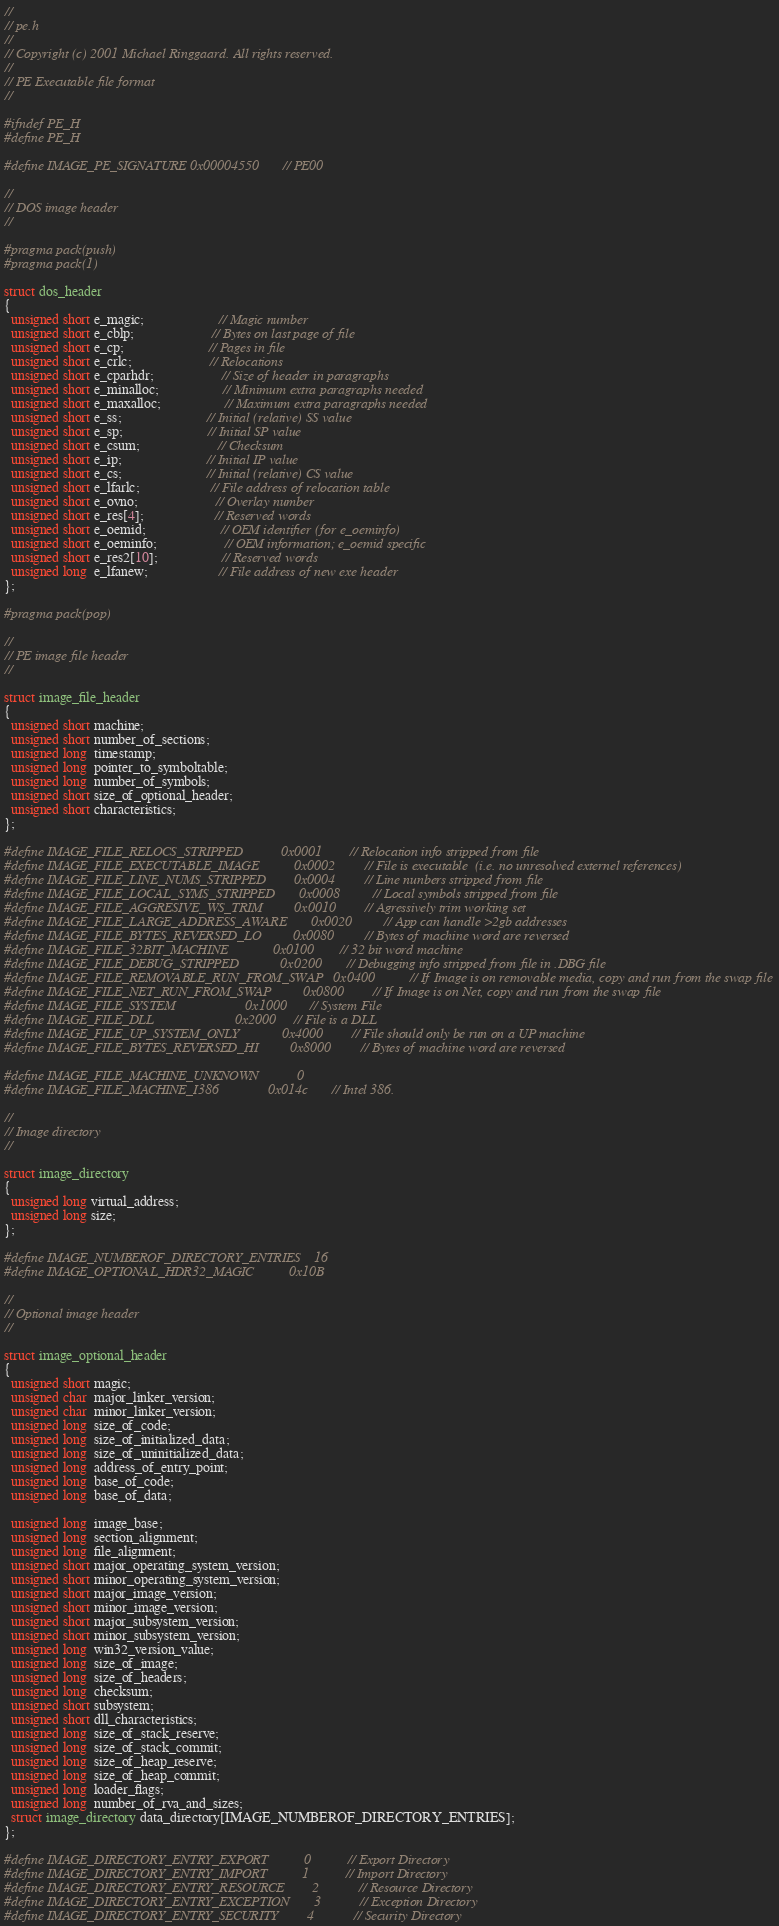<code> <loc_0><loc_0><loc_500><loc_500><_C_>//
// pe.h
//
// Copyright (c) 2001 Michael Ringgaard. All rights reserved.
//
// PE Executable file format
//

#ifndef PE_H
#define PE_H

#define IMAGE_PE_SIGNATURE 0x00004550  // PE00

//
// DOS image header
//

#pragma pack(push)
#pragma pack(1)

struct dos_header 
{
  unsigned short e_magic;                     // Magic number
  unsigned short e_cblp;                      // Bytes on last page of file
  unsigned short e_cp;                        // Pages in file
  unsigned short e_crlc;                      // Relocations
  unsigned short e_cparhdr;                   // Size of header in paragraphs
  unsigned short e_minalloc;                  // Minimum extra paragraphs needed
  unsigned short e_maxalloc;                  // Maximum extra paragraphs needed
  unsigned short e_ss;                        // Initial (relative) SS value
  unsigned short e_sp;                        // Initial SP value
  unsigned short e_csum;                      // Checksum
  unsigned short e_ip;                        // Initial IP value
  unsigned short e_cs;                        // Initial (relative) CS value
  unsigned short e_lfarlc;                    // File address of relocation table
  unsigned short e_ovno;                      // Overlay number
  unsigned short e_res[4];                    // Reserved words
  unsigned short e_oemid;                     // OEM identifier (for e_oeminfo)
  unsigned short e_oeminfo;                   // OEM information; e_oemid specific
  unsigned short e_res2[10];                  // Reserved words
  unsigned long  e_lfanew;                    // File address of new exe header
};

#pragma pack(pop)

//
// PE image file header
//

struct image_file_header
{
  unsigned short machine;
  unsigned short number_of_sections;
  unsigned long  timestamp;
  unsigned long  pointer_to_symboltable;
  unsigned long  number_of_symbols;
  unsigned short size_of_optional_header;
  unsigned short characteristics;
};

#define IMAGE_FILE_RELOCS_STRIPPED           0x0001  // Relocation info stripped from file
#define IMAGE_FILE_EXECUTABLE_IMAGE          0x0002  // File is executable  (i.e. no unresolved externel references)
#define IMAGE_FILE_LINE_NUMS_STRIPPED        0x0004  // Line nunbers stripped from file
#define IMAGE_FILE_LOCAL_SYMS_STRIPPED       0x0008  // Local symbols stripped from file
#define IMAGE_FILE_AGGRESIVE_WS_TRIM         0x0010  // Agressively trim working set
#define IMAGE_FILE_LARGE_ADDRESS_AWARE       0x0020  // App can handle >2gb addresses
#define IMAGE_FILE_BYTES_REVERSED_LO         0x0080  // Bytes of machine word are reversed
#define IMAGE_FILE_32BIT_MACHINE             0x0100  // 32 bit word machine
#define IMAGE_FILE_DEBUG_STRIPPED            0x0200  // Debugging info stripped from file in .DBG file
#define IMAGE_FILE_REMOVABLE_RUN_FROM_SWAP   0x0400  // If Image is on removable media, copy and run from the swap file
#define IMAGE_FILE_NET_RUN_FROM_SWAP         0x0800  // If Image is on Net, copy and run from the swap file
#define IMAGE_FILE_SYSTEM                    0x1000  // System File
#define IMAGE_FILE_DLL                       0x2000  // File is a DLL
#define IMAGE_FILE_UP_SYSTEM_ONLY            0x4000  // File should only be run on a UP machine
#define IMAGE_FILE_BYTES_REVERSED_HI         0x8000  // Bytes of machine word are reversed

#define IMAGE_FILE_MACHINE_UNKNOWN           0
#define IMAGE_FILE_MACHINE_I386              0x014c  // Intel 386.

//
// Image directory
//

struct image_directory
{
  unsigned long virtual_address;
  unsigned long size;
};

#define IMAGE_NUMBEROF_DIRECTORY_ENTRIES    16
#define IMAGE_OPTIONAL_HDR32_MAGIC          0x10B

//
// Optional image header
//

struct image_optional_header
{
  unsigned short magic;
  unsigned char  major_linker_version;
  unsigned char  minor_linker_version;
  unsigned long  size_of_code;
  unsigned long  size_of_initialized_data;
  unsigned long  size_of_uninitialized_data;
  unsigned long  address_of_entry_point;
  unsigned long  base_of_code;
  unsigned long  base_of_data;

  unsigned long  image_base;
  unsigned long  section_alignment;
  unsigned long  file_alignment;
  unsigned short major_operating_system_version;
  unsigned short minor_operating_system_version;
  unsigned short major_image_version;
  unsigned short minor_image_version;
  unsigned short major_subsystem_version;
  unsigned short minor_subsystem_version;
  unsigned long  win32_version_value;
  unsigned long  size_of_image;
  unsigned long  size_of_headers;
  unsigned long  checksum;
  unsigned short subsystem;
  unsigned short dll_characteristics;
  unsigned long  size_of_stack_reserve;
  unsigned long  size_of_stack_commit;
  unsigned long  size_of_heap_reserve;
  unsigned long  size_of_heap_commit;
  unsigned long  loader_flags;
  unsigned long  number_of_rva_and_sizes;
  struct image_directory data_directory[IMAGE_NUMBEROF_DIRECTORY_ENTRIES];
};

#define IMAGE_DIRECTORY_ENTRY_EXPORT          0   // Export Directory
#define IMAGE_DIRECTORY_ENTRY_IMPORT          1   // Import Directory
#define IMAGE_DIRECTORY_ENTRY_RESOURCE        2   // Resource Directory
#define IMAGE_DIRECTORY_ENTRY_EXCEPTION       3   // Exception Directory
#define IMAGE_DIRECTORY_ENTRY_SECURITY        4   // Security Directory</code> 